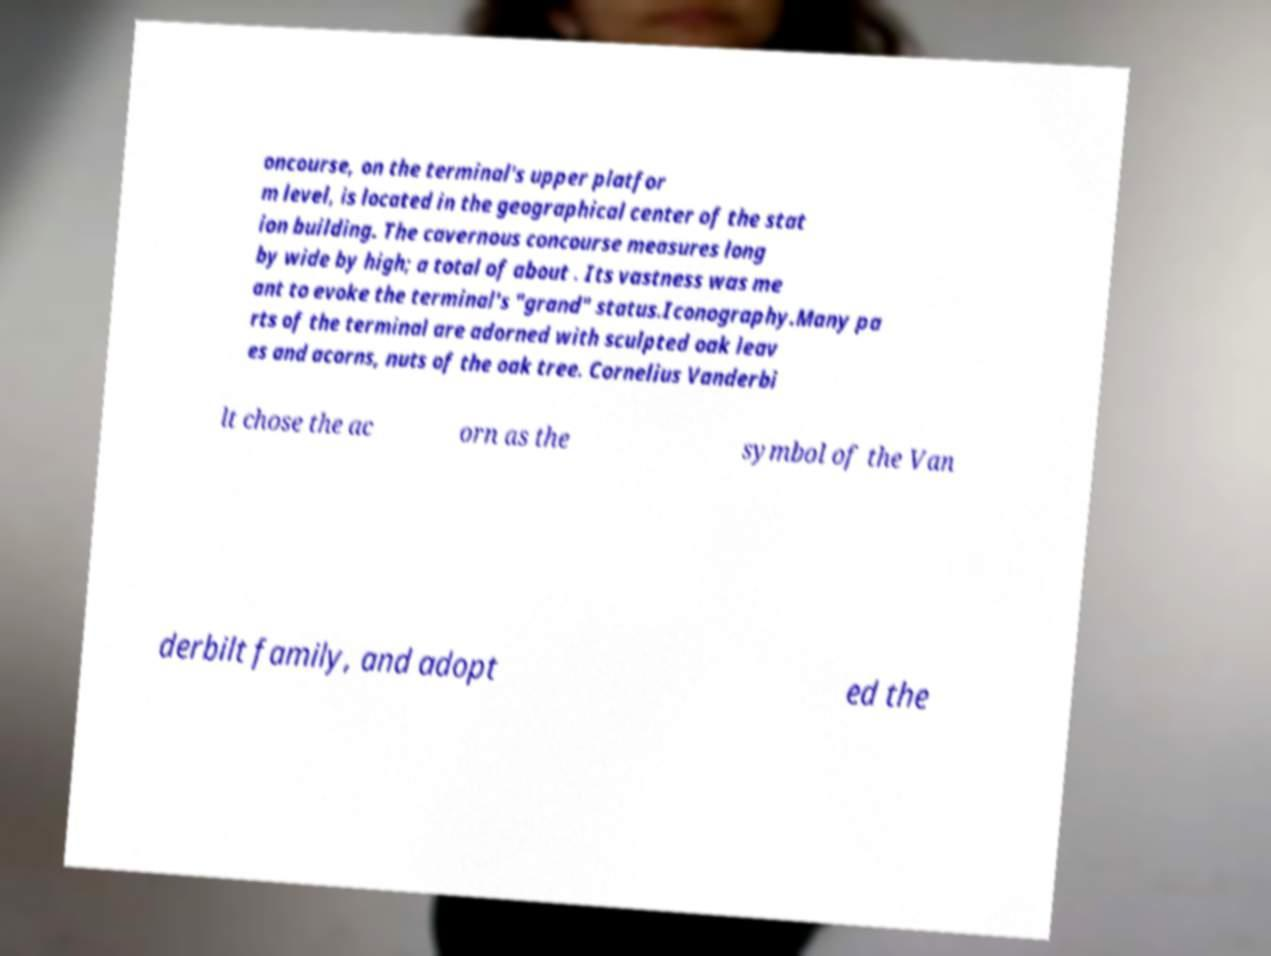Can you read and provide the text displayed in the image?This photo seems to have some interesting text. Can you extract and type it out for me? oncourse, on the terminal's upper platfor m level, is located in the geographical center of the stat ion building. The cavernous concourse measures long by wide by high; a total of about . Its vastness was me ant to evoke the terminal's "grand" status.Iconography.Many pa rts of the terminal are adorned with sculpted oak leav es and acorns, nuts of the oak tree. Cornelius Vanderbi lt chose the ac orn as the symbol of the Van derbilt family, and adopt ed the 